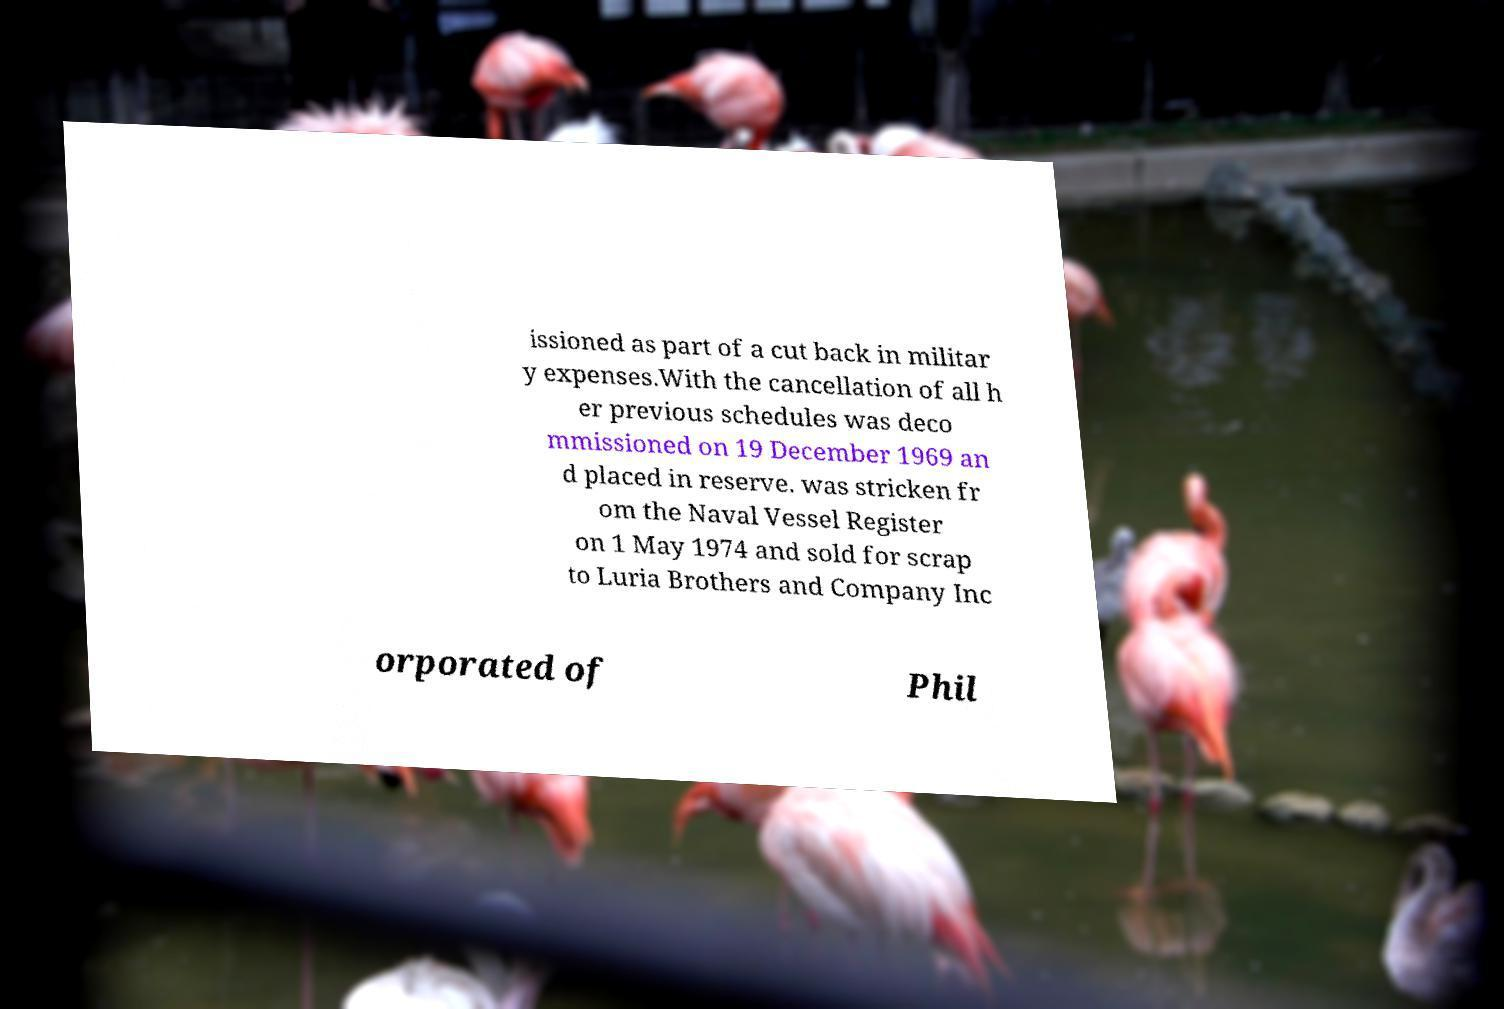What messages or text are displayed in this image? I need them in a readable, typed format. issioned as part of a cut back in militar y expenses.With the cancellation of all h er previous schedules was deco mmissioned on 19 December 1969 an d placed in reserve. was stricken fr om the Naval Vessel Register on 1 May 1974 and sold for scrap to Luria Brothers and Company Inc orporated of Phil 